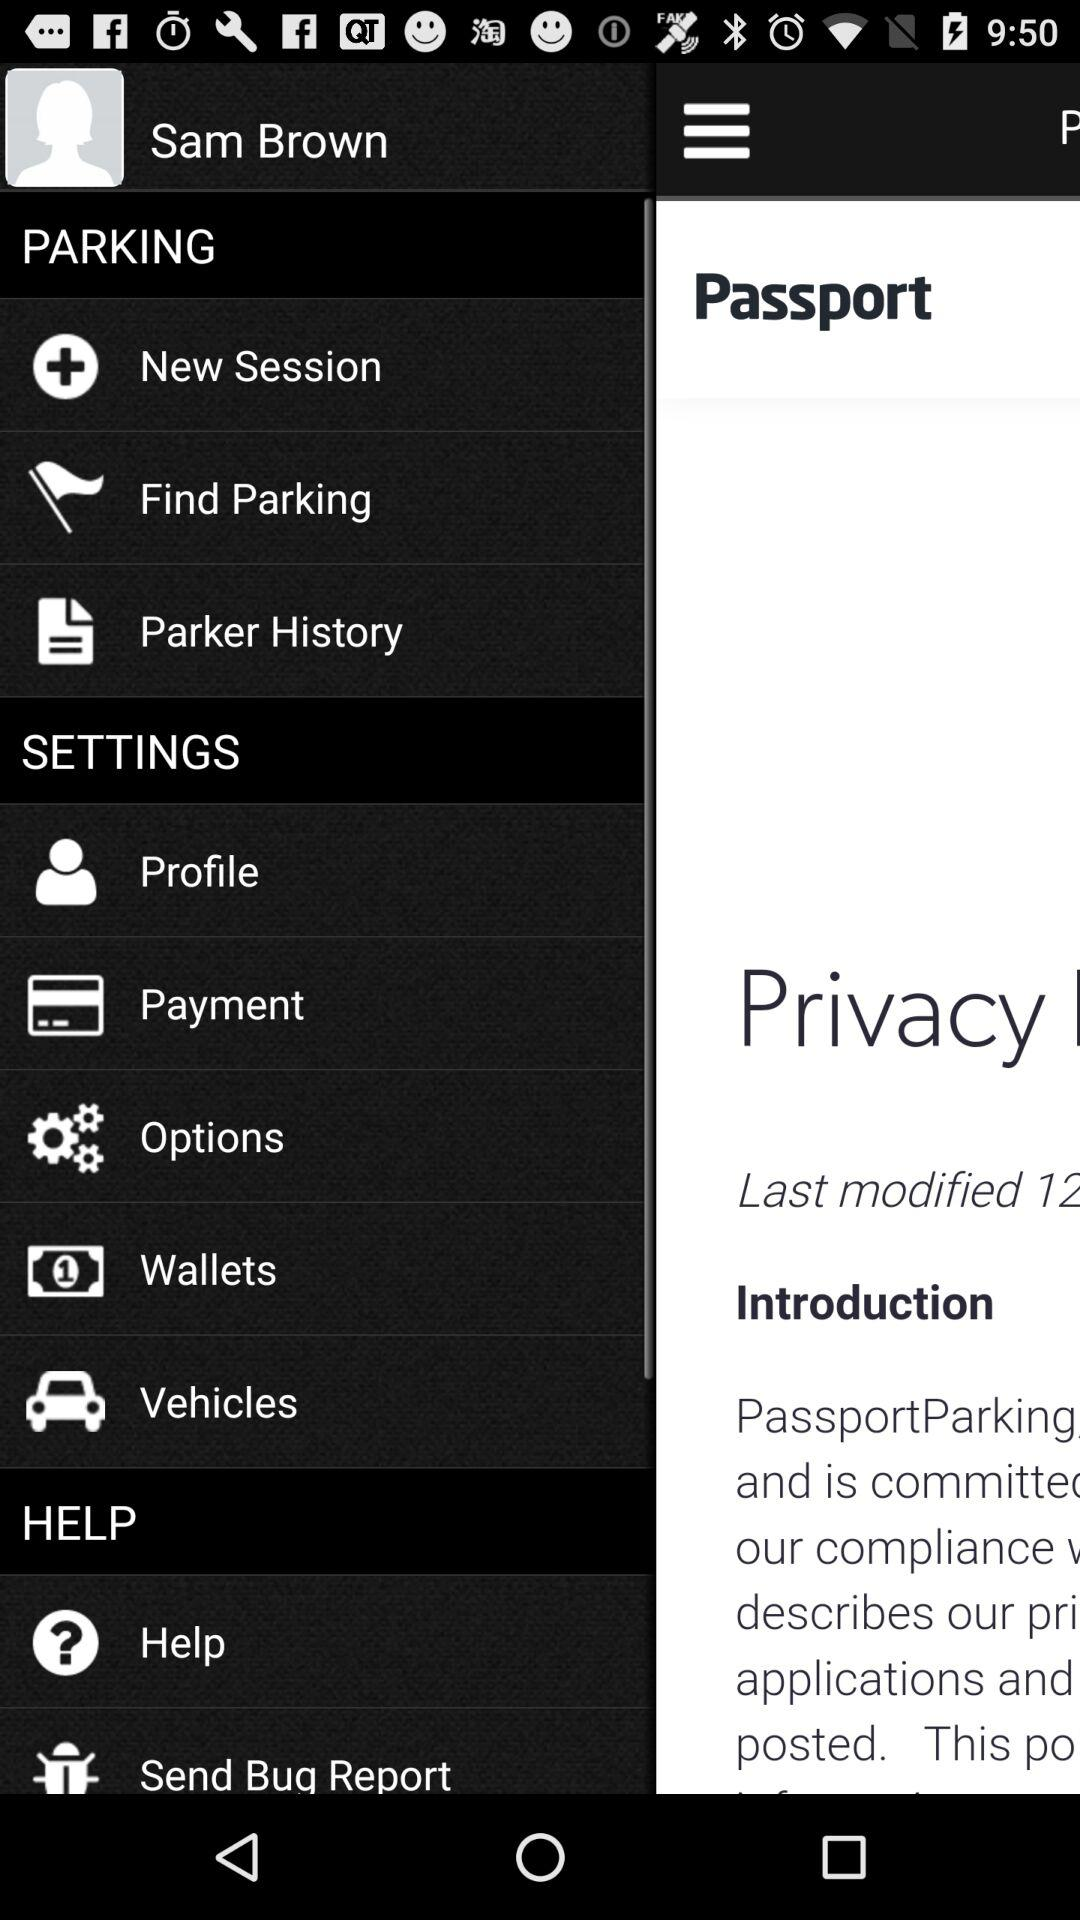What is the user name? The user name is Sam Brown. 